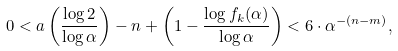<formula> <loc_0><loc_0><loc_500><loc_500>0 < a \left ( \frac { \log 2 } { \log \alpha } \right ) - n + \left ( 1 - \frac { \log f _ { k } ( \alpha ) } { \log \alpha } \right ) < 6 \cdot \alpha ^ { - ( n - m ) } ,</formula> 